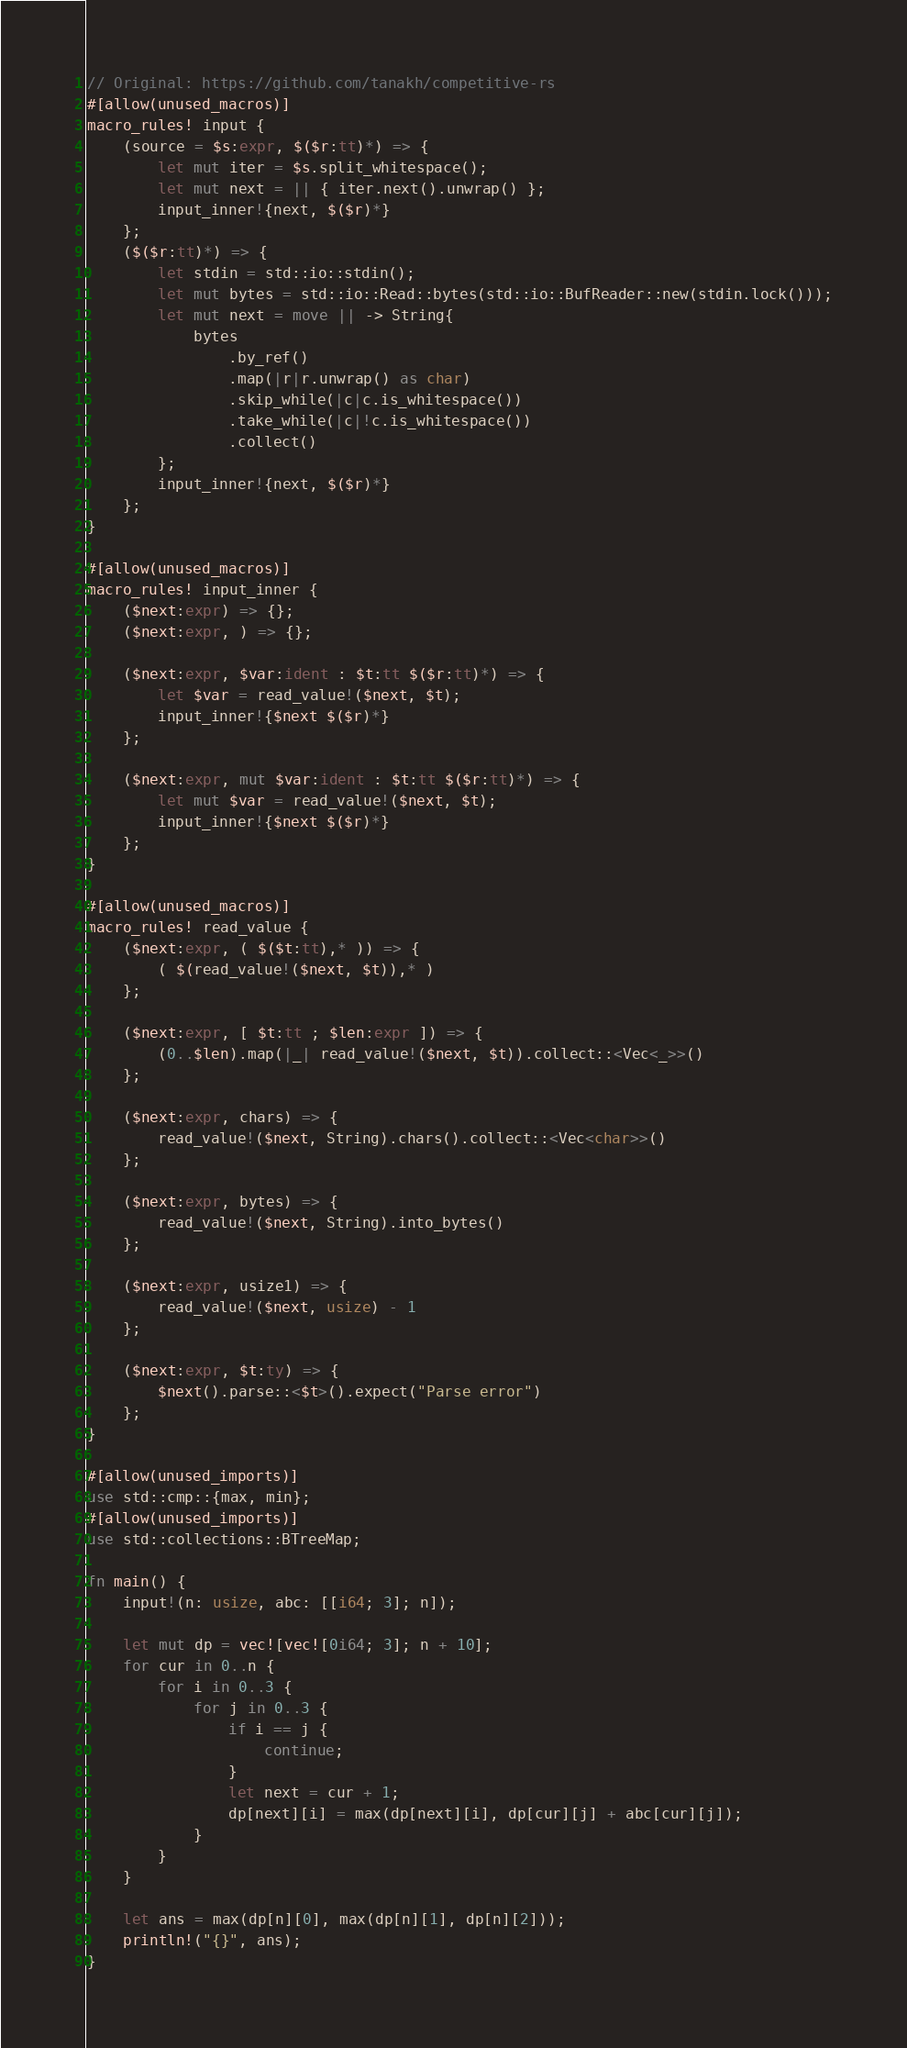<code> <loc_0><loc_0><loc_500><loc_500><_Rust_>// Original: https://github.com/tanakh/competitive-rs
#[allow(unused_macros)]
macro_rules! input {
    (source = $s:expr, $($r:tt)*) => {
        let mut iter = $s.split_whitespace();
        let mut next = || { iter.next().unwrap() };
        input_inner!{next, $($r)*}
    };
    ($($r:tt)*) => {
        let stdin = std::io::stdin();
        let mut bytes = std::io::Read::bytes(std::io::BufReader::new(stdin.lock()));
        let mut next = move || -> String{
            bytes
                .by_ref()
                .map(|r|r.unwrap() as char)
                .skip_while(|c|c.is_whitespace())
                .take_while(|c|!c.is_whitespace())
                .collect()
        };
        input_inner!{next, $($r)*}
    };
}

#[allow(unused_macros)]
macro_rules! input_inner {
    ($next:expr) => {};
    ($next:expr, ) => {};

    ($next:expr, $var:ident : $t:tt $($r:tt)*) => {
        let $var = read_value!($next, $t);
        input_inner!{$next $($r)*}
    };

    ($next:expr, mut $var:ident : $t:tt $($r:tt)*) => {
        let mut $var = read_value!($next, $t);
        input_inner!{$next $($r)*}
    };
}

#[allow(unused_macros)]
macro_rules! read_value {
    ($next:expr, ( $($t:tt),* )) => {
        ( $(read_value!($next, $t)),* )
    };

    ($next:expr, [ $t:tt ; $len:expr ]) => {
        (0..$len).map(|_| read_value!($next, $t)).collect::<Vec<_>>()
    };

    ($next:expr, chars) => {
        read_value!($next, String).chars().collect::<Vec<char>>()
    };

    ($next:expr, bytes) => {
        read_value!($next, String).into_bytes()
    };

    ($next:expr, usize1) => {
        read_value!($next, usize) - 1
    };

    ($next:expr, $t:ty) => {
        $next().parse::<$t>().expect("Parse error")
    };
}

#[allow(unused_imports)]
use std::cmp::{max, min};
#[allow(unused_imports)]
use std::collections::BTreeMap;

fn main() {
    input!(n: usize, abc: [[i64; 3]; n]);

    let mut dp = vec![vec![0i64; 3]; n + 10];
    for cur in 0..n {
        for i in 0..3 {
            for j in 0..3 {
                if i == j {
                    continue;
                }
                let next = cur + 1;
                dp[next][i] = max(dp[next][i], dp[cur][j] + abc[cur][j]);
            }
        }
    }

    let ans = max(dp[n][0], max(dp[n][1], dp[n][2]));
    println!("{}", ans);
}
</code> 